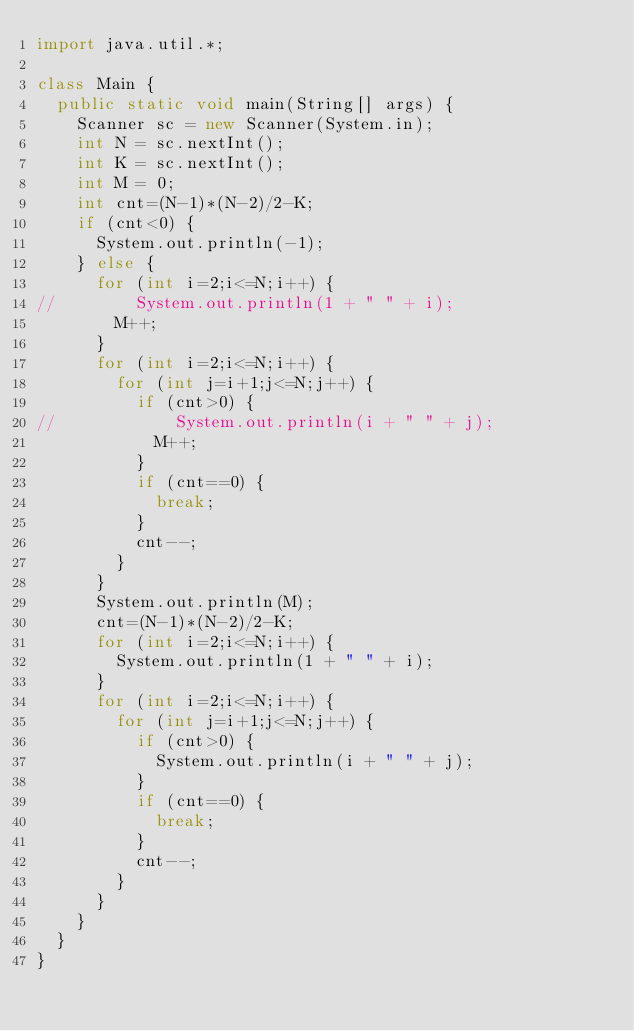Convert code to text. <code><loc_0><loc_0><loc_500><loc_500><_Java_>import java.util.*;

class Main {
	public static void main(String[] args) {
		Scanner sc = new Scanner(System.in);
		int N = sc.nextInt();
		int K = sc.nextInt();
		int M = 0;
		int cnt=(N-1)*(N-2)/2-K;
		if (cnt<0) {
			System.out.println(-1);
		} else {
			for (int i=2;i<=N;i++) {
//				System.out.println(1 + " " + i);
				M++;
			}
			for (int i=2;i<=N;i++) {
				for (int j=i+1;j<=N;j++) {
					if (cnt>0) {
//						System.out.println(i + " " + j);
						M++;
					}
					if (cnt==0) {
						break;
					}
					cnt--;
				}
			}
			System.out.println(M);
			cnt=(N-1)*(N-2)/2-K;
			for (int i=2;i<=N;i++) {
				System.out.println(1 + " " + i);
			}
			for (int i=2;i<=N;i++) {
				for (int j=i+1;j<=N;j++) {
					if (cnt>0) {
						System.out.println(i + " " + j);
					}
					if (cnt==0) {
						break;
					}
					cnt--;
				}
			}
		}
	}
}</code> 